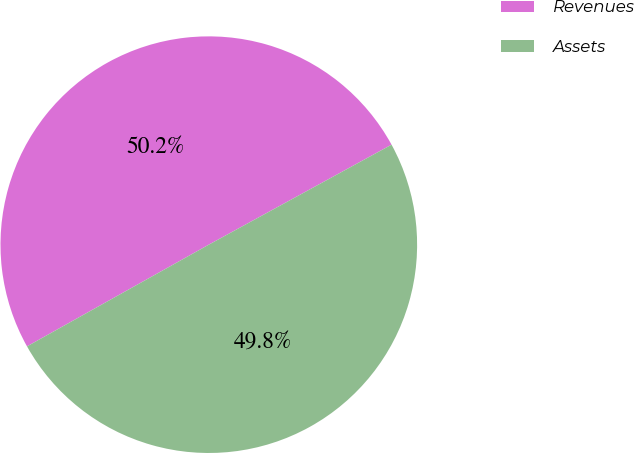Convert chart. <chart><loc_0><loc_0><loc_500><loc_500><pie_chart><fcel>Revenues<fcel>Assets<nl><fcel>50.15%<fcel>49.85%<nl></chart> 